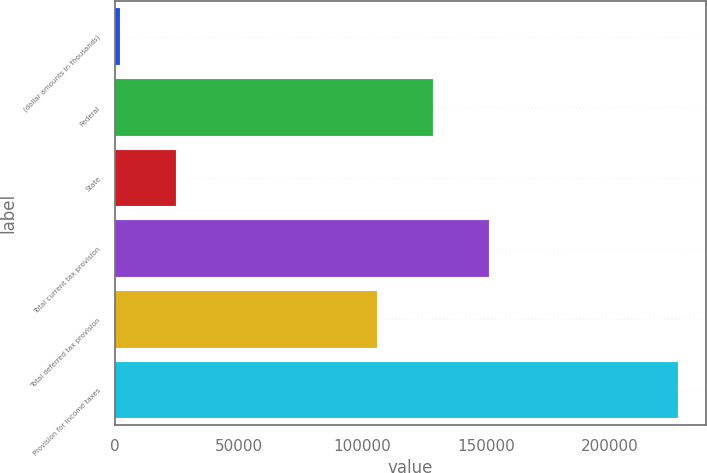<chart> <loc_0><loc_0><loc_500><loc_500><bar_chart><fcel>(dollar amounts in thousands)<fcel>Federal<fcel>State<fcel>Total current tax provision<fcel>Total deferred tax provision<fcel>Provision for income taxes<nl><fcel>2013<fcel>128568<fcel>24559.1<fcel>151114<fcel>106022<fcel>227474<nl></chart> 